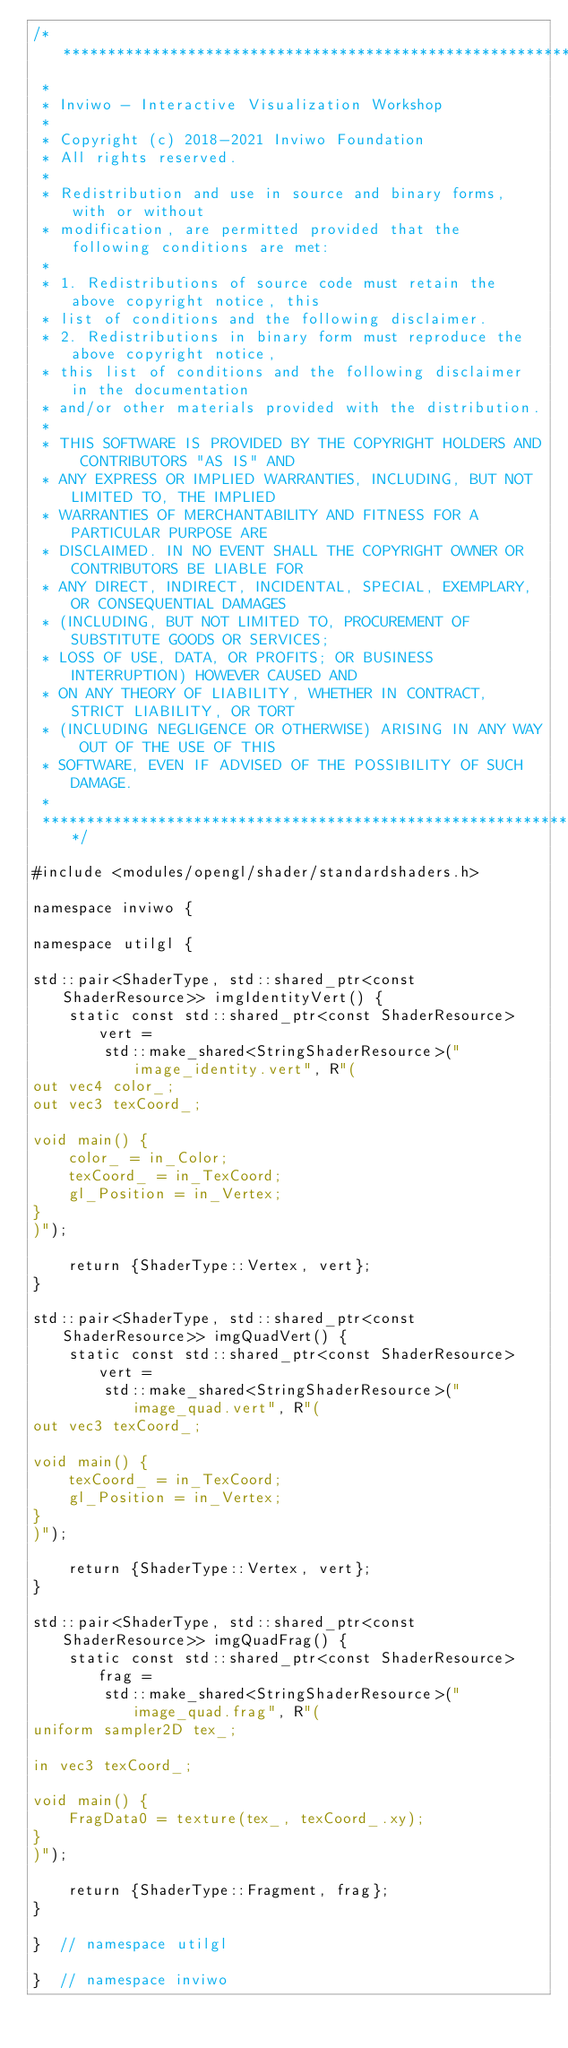Convert code to text. <code><loc_0><loc_0><loc_500><loc_500><_C++_>/*********************************************************************************
 *
 * Inviwo - Interactive Visualization Workshop
 *
 * Copyright (c) 2018-2021 Inviwo Foundation
 * All rights reserved.
 *
 * Redistribution and use in source and binary forms, with or without
 * modification, are permitted provided that the following conditions are met:
 *
 * 1. Redistributions of source code must retain the above copyright notice, this
 * list of conditions and the following disclaimer.
 * 2. Redistributions in binary form must reproduce the above copyright notice,
 * this list of conditions and the following disclaimer in the documentation
 * and/or other materials provided with the distribution.
 *
 * THIS SOFTWARE IS PROVIDED BY THE COPYRIGHT HOLDERS AND CONTRIBUTORS "AS IS" AND
 * ANY EXPRESS OR IMPLIED WARRANTIES, INCLUDING, BUT NOT LIMITED TO, THE IMPLIED
 * WARRANTIES OF MERCHANTABILITY AND FITNESS FOR A PARTICULAR PURPOSE ARE
 * DISCLAIMED. IN NO EVENT SHALL THE COPYRIGHT OWNER OR CONTRIBUTORS BE LIABLE FOR
 * ANY DIRECT, INDIRECT, INCIDENTAL, SPECIAL, EXEMPLARY, OR CONSEQUENTIAL DAMAGES
 * (INCLUDING, BUT NOT LIMITED TO, PROCUREMENT OF SUBSTITUTE GOODS OR SERVICES;
 * LOSS OF USE, DATA, OR PROFITS; OR BUSINESS INTERRUPTION) HOWEVER CAUSED AND
 * ON ANY THEORY OF LIABILITY, WHETHER IN CONTRACT, STRICT LIABILITY, OR TORT
 * (INCLUDING NEGLIGENCE OR OTHERWISE) ARISING IN ANY WAY OUT OF THE USE OF THIS
 * SOFTWARE, EVEN IF ADVISED OF THE POSSIBILITY OF SUCH DAMAGE.
 *
 *********************************************************************************/

#include <modules/opengl/shader/standardshaders.h>

namespace inviwo {

namespace utilgl {

std::pair<ShaderType, std::shared_ptr<const ShaderResource>> imgIdentityVert() {
    static const std::shared_ptr<const ShaderResource> vert =
        std::make_shared<StringShaderResource>("image_identity.vert", R"(
out vec4 color_;
out vec3 texCoord_;

void main() {
    color_ = in_Color;
    texCoord_ = in_TexCoord;
    gl_Position = in_Vertex;
}
)");

    return {ShaderType::Vertex, vert};
}

std::pair<ShaderType, std::shared_ptr<const ShaderResource>> imgQuadVert() {
    static const std::shared_ptr<const ShaderResource> vert =
        std::make_shared<StringShaderResource>("image_quad.vert", R"(
out vec3 texCoord_;

void main() {
    texCoord_ = in_TexCoord;
    gl_Position = in_Vertex;
}
)");

    return {ShaderType::Vertex, vert};
}

std::pair<ShaderType, std::shared_ptr<const ShaderResource>> imgQuadFrag() {
    static const std::shared_ptr<const ShaderResource> frag =
        std::make_shared<StringShaderResource>("image_quad.frag", R"(
uniform sampler2D tex_;

in vec3 texCoord_;

void main() {
    FragData0 = texture(tex_, texCoord_.xy);
}
)");

    return {ShaderType::Fragment, frag};
}

}  // namespace utilgl

}  // namespace inviwo
</code> 